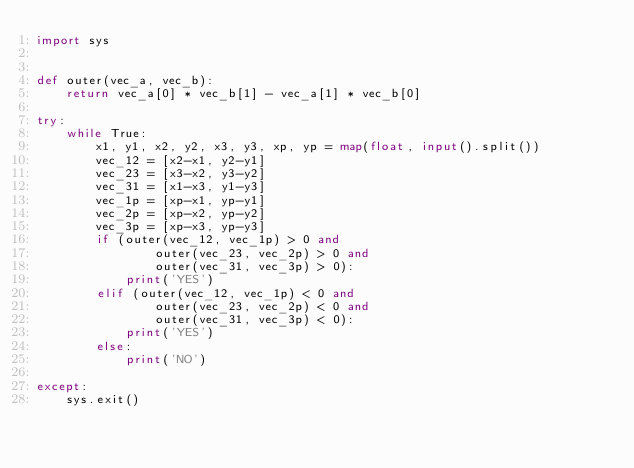<code> <loc_0><loc_0><loc_500><loc_500><_Python_>import sys


def outer(vec_a, vec_b):
    return vec_a[0] * vec_b[1] - vec_a[1] * vec_b[0]

try:
    while True:
        x1, y1, x2, y2, x3, y3, xp, yp = map(float, input().split())
        vec_12 = [x2-x1, y2-y1]
        vec_23 = [x3-x2, y3-y2]
        vec_31 = [x1-x3, y1-y3]
        vec_1p = [xp-x1, yp-y1]
        vec_2p = [xp-x2, yp-y2]
        vec_3p = [xp-x3, yp-y3]
        if (outer(vec_12, vec_1p) > 0 and
                outer(vec_23, vec_2p) > 0 and
                outer(vec_31, vec_3p) > 0):
            print('YES')
        elif (outer(vec_12, vec_1p) < 0 and
                outer(vec_23, vec_2p) < 0 and
                outer(vec_31, vec_3p) < 0):
            print('YES')
        else:
            print('NO')

except:
    sys.exit()</code> 